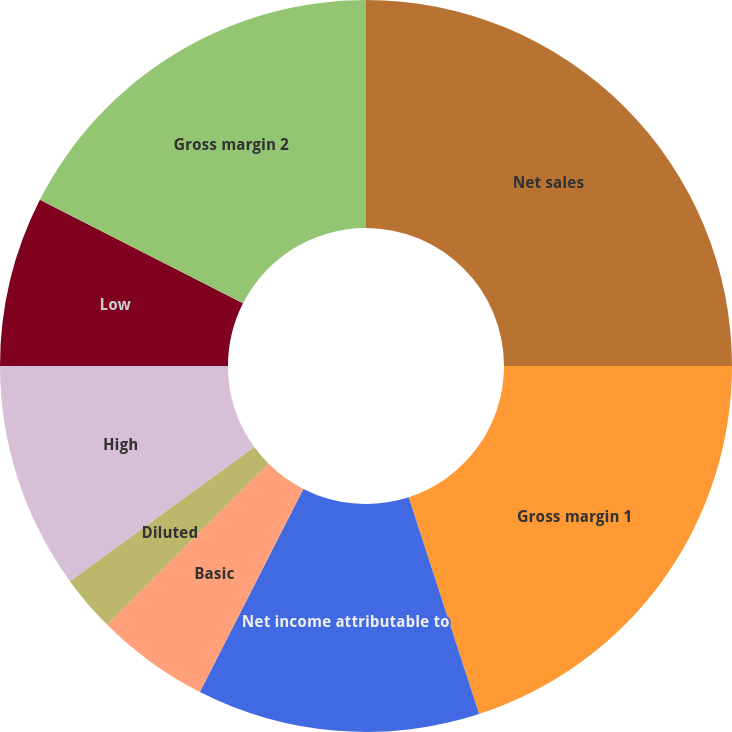<chart> <loc_0><loc_0><loc_500><loc_500><pie_chart><fcel>Net sales<fcel>Gross margin 1<fcel>Net income attributable to<fcel>Basic<fcel>Diluted<fcel>Cash dividends declared per<fcel>High<fcel>Low<fcel>Gross margin 2<nl><fcel>25.0%<fcel>20.0%<fcel>12.5%<fcel>5.0%<fcel>2.5%<fcel>0.0%<fcel>10.0%<fcel>7.5%<fcel>17.5%<nl></chart> 